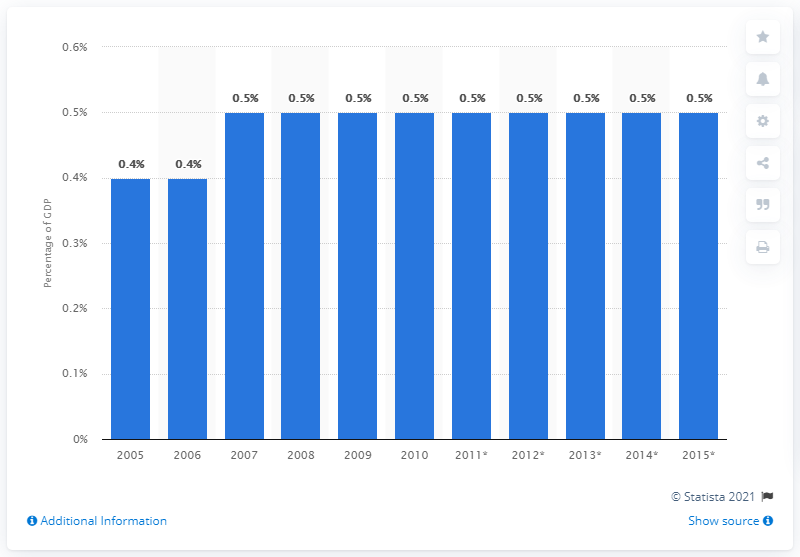Indicate a few pertinent items in this graphic. The expected share of IT services on total GDP in 2012 was 0.5%. 